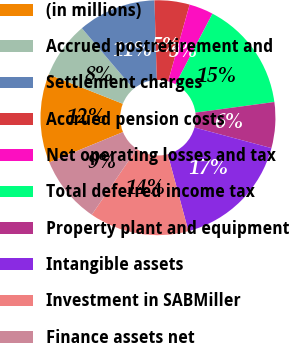Convert chart. <chart><loc_0><loc_0><loc_500><loc_500><pie_chart><fcel>(in millions)<fcel>Accrued postretirement and<fcel>Settlement charges<fcel>Accrued pension costs<fcel>Net operating losses and tax<fcel>Total deferred income tax<fcel>Property plant and equipment<fcel>Intangible assets<fcel>Investment in SABMiller<fcel>Finance assets net<nl><fcel>12.22%<fcel>7.78%<fcel>10.74%<fcel>4.82%<fcel>3.34%<fcel>15.18%<fcel>6.3%<fcel>16.66%<fcel>13.7%<fcel>9.26%<nl></chart> 